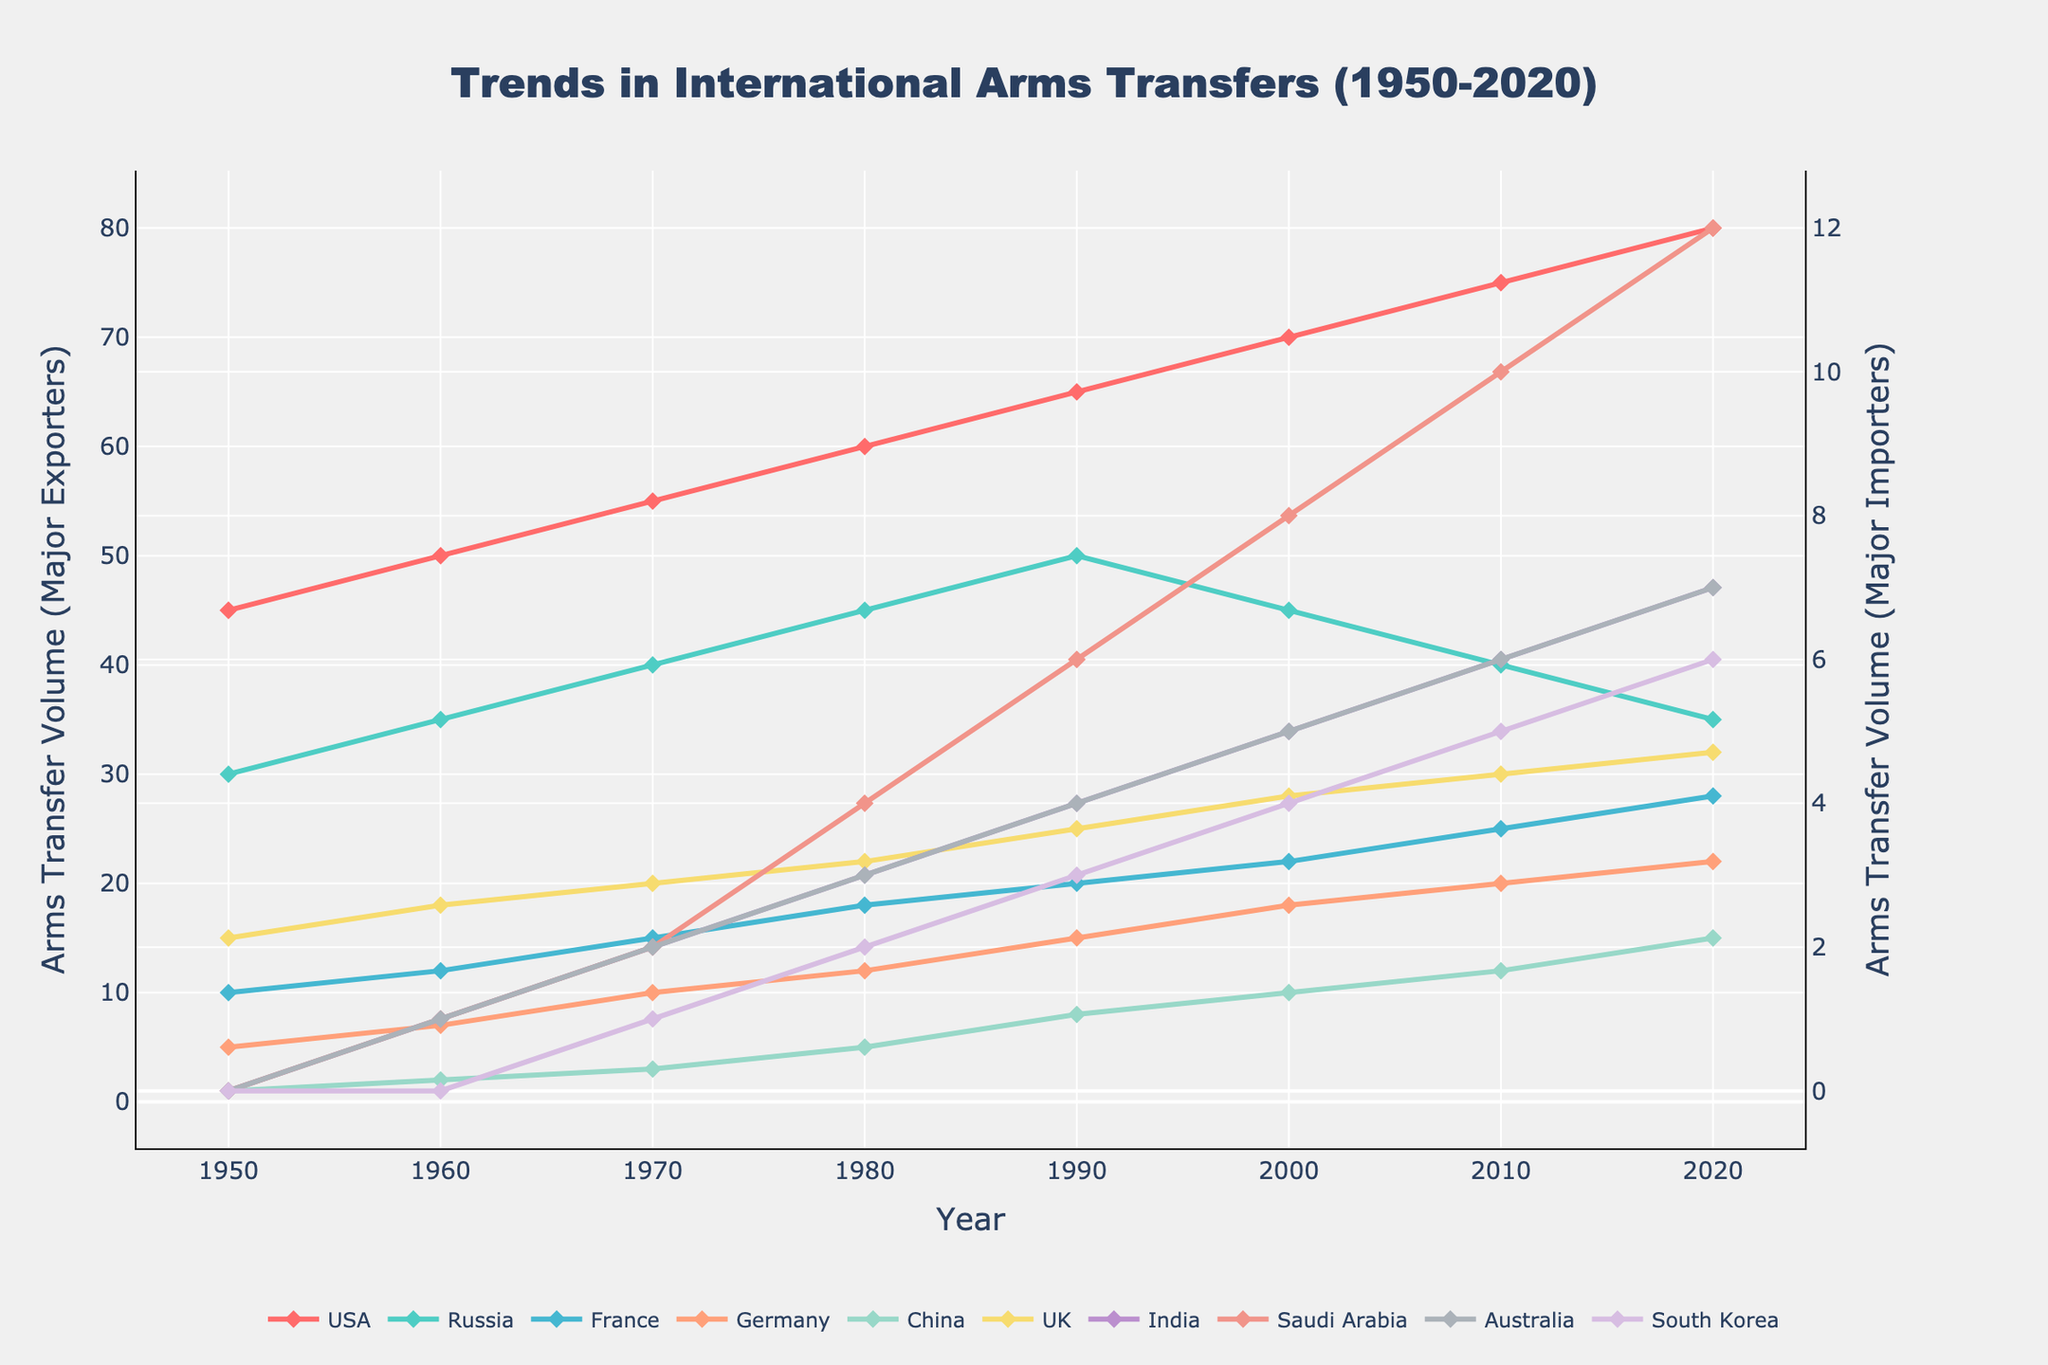What are the trends in arms transfers for the USA from 1950 to 2020? To determine the trends in arms transfers for the USA, observe the data points on the chart for the USA (marked in one of the distinguishable colors). The USA's arms transfers show a steady increase from 45 units in 1950 to 80 units in 2020.
Answer: Steady increase Between 1950 and 2020, which country showed the biggest decrease in arms transfers? To find the country with the biggest decrease, observe the slopes of each country's trend lines from 1950 to 2020. Russia showed the biggest decrease, starting from 30 units in 1950 and ending at 35 units in 2020.
Answer: Russia In 2020, what is the combined volume of arms transfers for France and Germany? Add France's 28 units to Germany's 22 units from the 2020 data. 28 + 22 = 50 units.
Answer: 50 units Compare the arms transfer trends of India and China from 1950 to 2020. Who showed a more significant increase? For India, look at the line trend from 0 units in 1950 to 7 units in 2020. For China, the trend goes from 1 unit in 1950 to 15 units in 2020. China showed a more significant increase.
Answer: China In which year did Saudi Arabia surpass India in arms transfer volume? Locate the point where Saudi Arabia's line crosses above India's. This occurs in 1980 when Saudi Arabia rises to 4 units, surpassing India at 3 units.
Answer: 1980 Which country had the highest arms transfer volume in 1990 among the five major importers? Check the volumes for India, Saudi Arabia, Australia, and South Korea in 1990. The largest value is seen for Saudi Arabia at 6 units.
Answer: Saudi Arabia What can be inferred about the trends in arms transfers for Russia between 2000 and 2020? Observe Russia's data points from 2000 to 2020. The volume decreases from 45 units in 2000 to 35 units in 2020, indicating a downward trend.
Answer: Downward trend How does the trend in arms transfers for China compare to the UK from 1950 to 2020? Examine their first and last values and trend lines. China starts at 1 unit and rises to 15 units, while the UK starts at 15 units and increases to 32 units, showing a consistent upward trend for both but with a larger net volume for the UK.
Answer: Both increasing, UK has a larger net volume What is the average arms transfer volume for Germany over the period 1950 to 2020? Sum the data points for Germany from 1950 to 2020 and divide by the number of years. (5+7+10+12+15+18+20+22)/8 = 13.625 units.
Answer: 13.625 units Were the arms transfers for South Korea consistently rising, falling, or fluctuating from 1950 to 2020? Observe the trend line for South Korea from 1950 to 2020. The arms transfers show a consistent increase from 0 units in 1950 to 6 units in 2020.
Answer: Consistently rising 